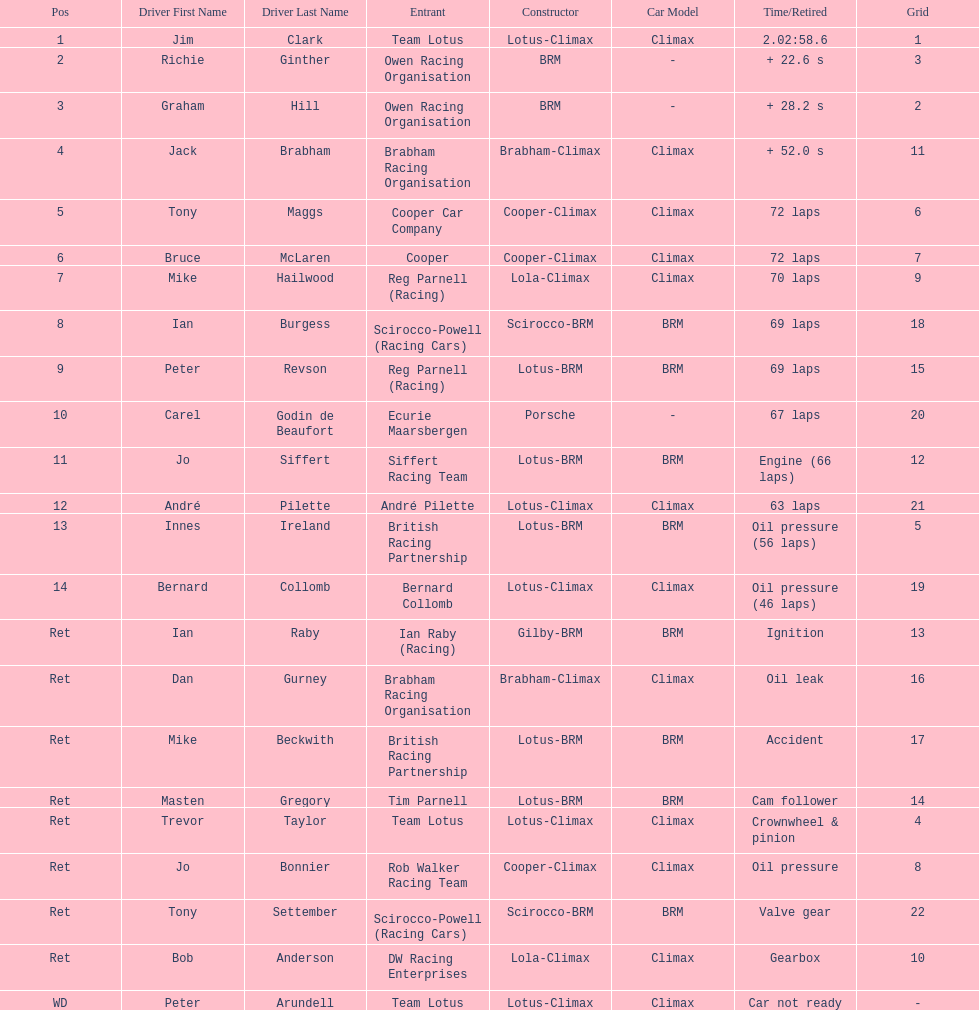Who was the top finisher that drove a cooper-climax? Tony Maggs. 